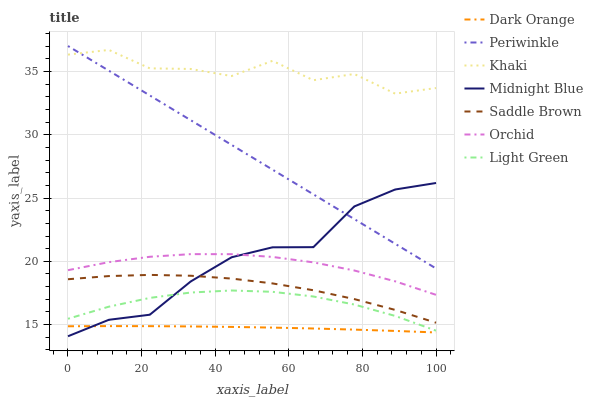Does Dark Orange have the minimum area under the curve?
Answer yes or no. Yes. Does Khaki have the maximum area under the curve?
Answer yes or no. Yes. Does Midnight Blue have the minimum area under the curve?
Answer yes or no. No. Does Midnight Blue have the maximum area under the curve?
Answer yes or no. No. Is Periwinkle the smoothest?
Answer yes or no. Yes. Is Khaki the roughest?
Answer yes or no. Yes. Is Midnight Blue the smoothest?
Answer yes or no. No. Is Midnight Blue the roughest?
Answer yes or no. No. Does Khaki have the lowest value?
Answer yes or no. No. Does Periwinkle have the highest value?
Answer yes or no. Yes. Does Khaki have the highest value?
Answer yes or no. No. Is Dark Orange less than Khaki?
Answer yes or no. Yes. Is Khaki greater than Light Green?
Answer yes or no. Yes. Does Orchid intersect Midnight Blue?
Answer yes or no. Yes. Is Orchid less than Midnight Blue?
Answer yes or no. No. Is Orchid greater than Midnight Blue?
Answer yes or no. No. Does Dark Orange intersect Khaki?
Answer yes or no. No. 